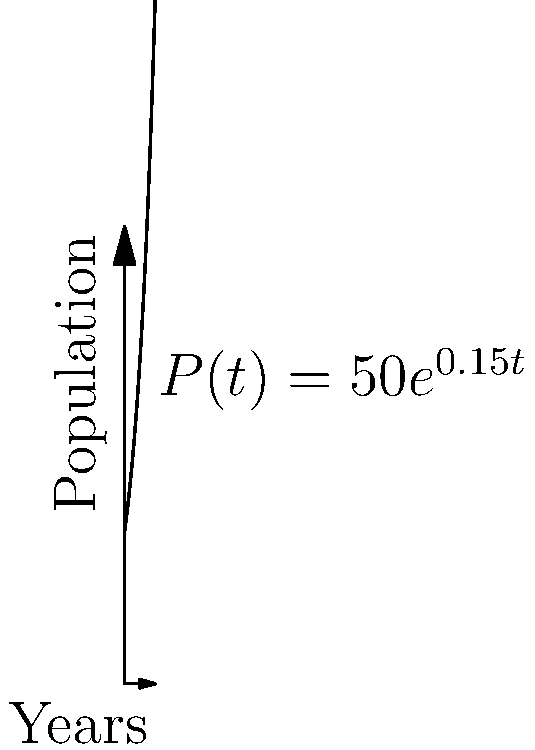A commune in rural California started with 50 members in 1967. The population grew exponentially, following the function $P(t) = 50e^{0.15t}$, where $P(t)$ is the population after $t$ years. What was the annual growth rate of the commune's population? To find the annual growth rate, we need to analyze the exponential function $P(t) = 50e^{0.15t}$.

1) The general form of an exponential growth function is $P(t) = P_0e^{rt}$, where:
   $P_0$ is the initial population
   $r$ is the growth rate
   $t$ is the time in years

2) Comparing our function to the general form:
   $P(t) = 50e^{0.15t}$
   $P_0 = 50$
   $r = 0.15$

3) The growth rate $r$ in the exponential function represents the continuous growth rate.

4) To convert this to an annual growth rate, we use the formula:
   Annual Growth Rate = $e^r - 1$

5) Plugging in our $r$ value:
   Annual Growth Rate = $e^{0.15} - 1$

6) Calculating:
   Annual Growth Rate = $1.1618 - 1 = 0.1618$

7) Convert to a percentage:
   0.1618 * 100% = 16.18%

Therefore, the annual growth rate of the commune's population was approximately 16.18%.
Answer: 16.18% 